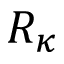Convert formula to latex. <formula><loc_0><loc_0><loc_500><loc_500>R _ { \kappa }</formula> 